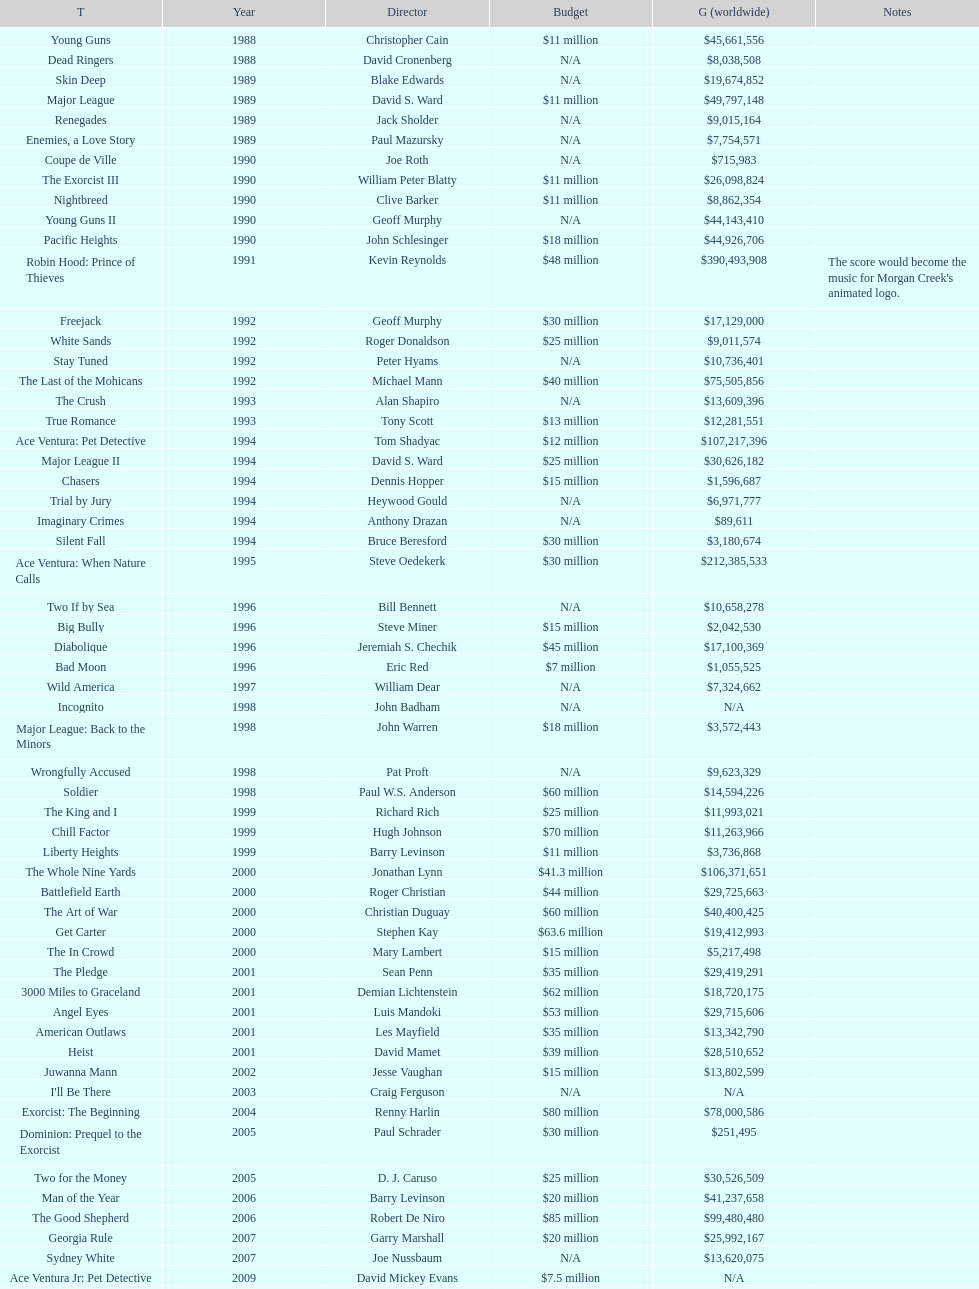What is the top grossing film? Robin Hood: Prince of Thieves. 